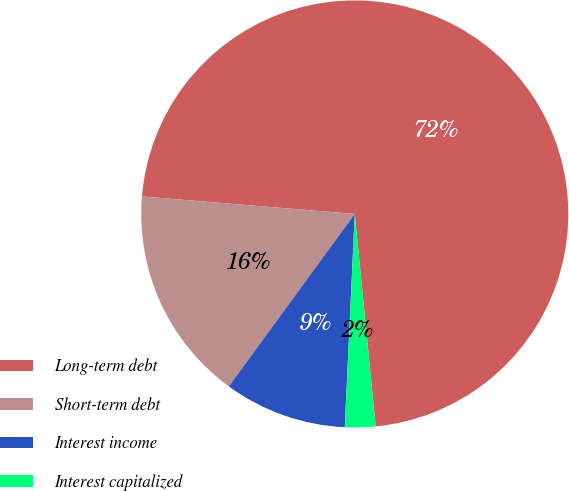Convert chart to OTSL. <chart><loc_0><loc_0><loc_500><loc_500><pie_chart><fcel>Long-term debt<fcel>Short-term debt<fcel>Interest income<fcel>Interest capitalized<nl><fcel>72.12%<fcel>16.27%<fcel>9.29%<fcel>2.31%<nl></chart> 